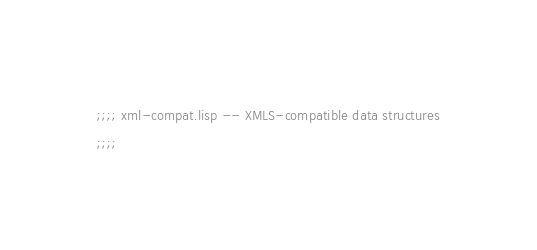Convert code to text. <code><loc_0><loc_0><loc_500><loc_500><_Lisp_>;;;; xml-compat.lisp -- XMLS-compatible data structures
;;;;</code> 